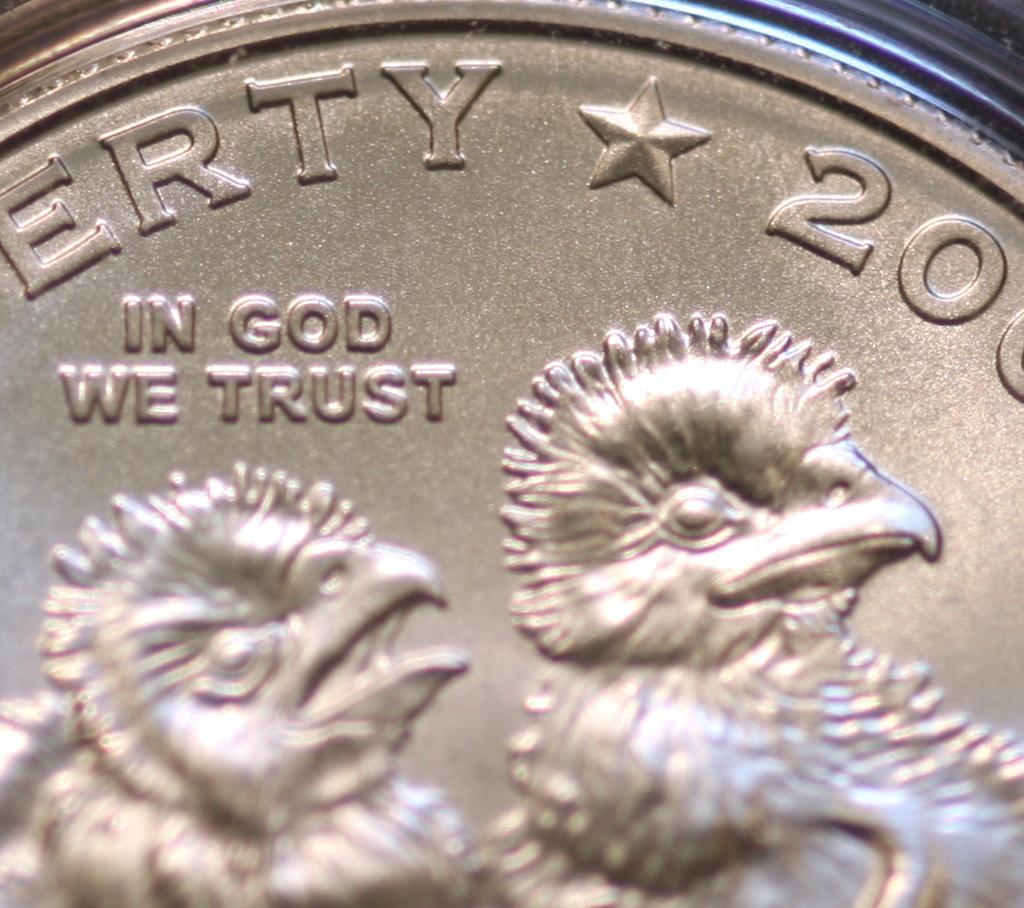What does the sign say?
Provide a short and direct response. Unanswerable. What is the first number on the coin?
Your answer should be very brief. 2. 